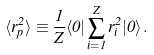Convert formula to latex. <formula><loc_0><loc_0><loc_500><loc_500>\langle r _ { p } ^ { 2 } \rangle \equiv \frac { 1 } { Z } \langle 0 | \sum _ { i = 1 } ^ { Z } r _ { i } ^ { 2 } | 0 \rangle \, .</formula> 